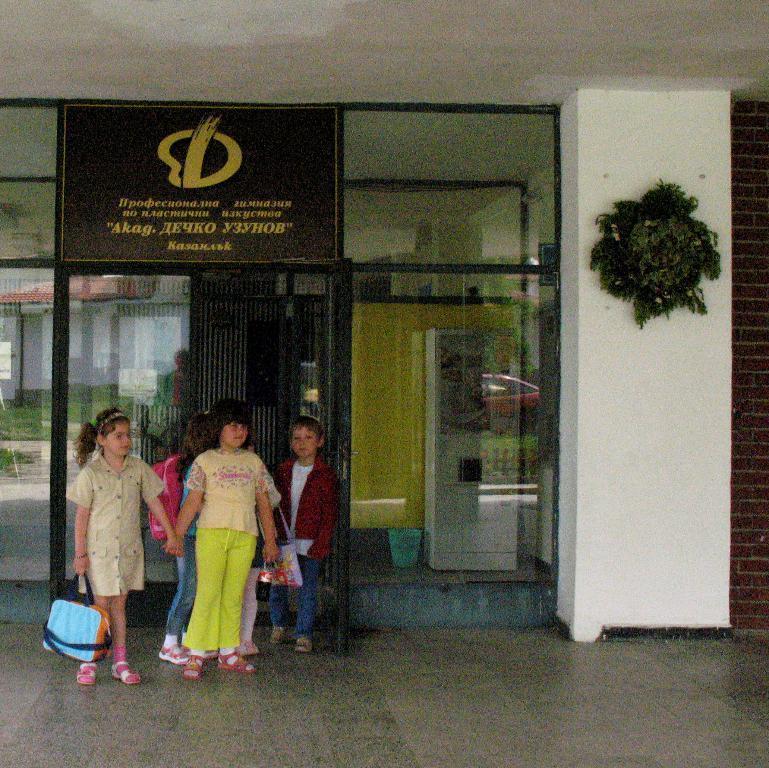Can you describe this image briefly? There are few kids standing and there are some other objects behind them. 